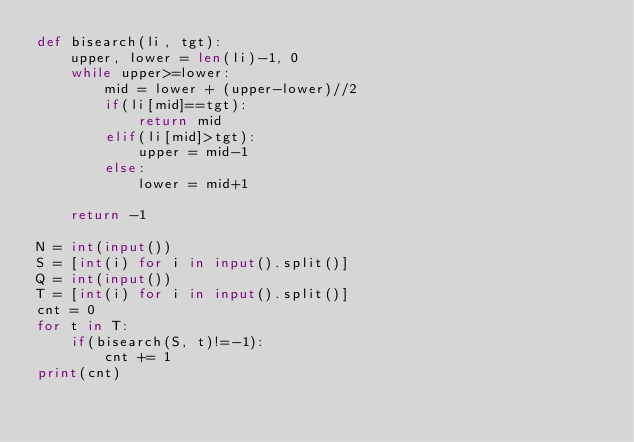<code> <loc_0><loc_0><loc_500><loc_500><_Python_>def bisearch(li, tgt):
    upper, lower = len(li)-1, 0
    while upper>=lower:
        mid = lower + (upper-lower)//2
        if(li[mid]==tgt):
            return mid
        elif(li[mid]>tgt):
            upper = mid-1
        else:
            lower = mid+1
        
    return -1

N = int(input())
S = [int(i) for i in input().split()]
Q = int(input())
T = [int(i) for i in input().split()]
cnt = 0
for t in T:
    if(bisearch(S, t)!=-1):
        cnt += 1
print(cnt)

</code> 